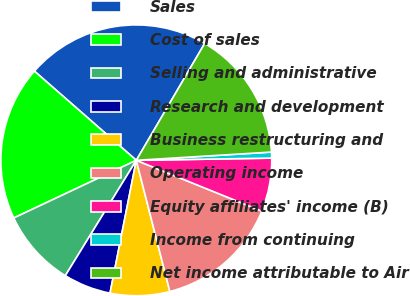<chart> <loc_0><loc_0><loc_500><loc_500><pie_chart><fcel>Sales<fcel>Cost of sales<fcel>Selling and administrative<fcel>Research and development<fcel>Business restructuring and<fcel>Operating income<fcel>Equity affiliates' income (B)<fcel>Income from continuing<fcel>Net income attributable to Air<nl><fcel>21.98%<fcel>18.44%<fcel>9.22%<fcel>5.67%<fcel>7.09%<fcel>14.89%<fcel>6.38%<fcel>0.71%<fcel>15.6%<nl></chart> 